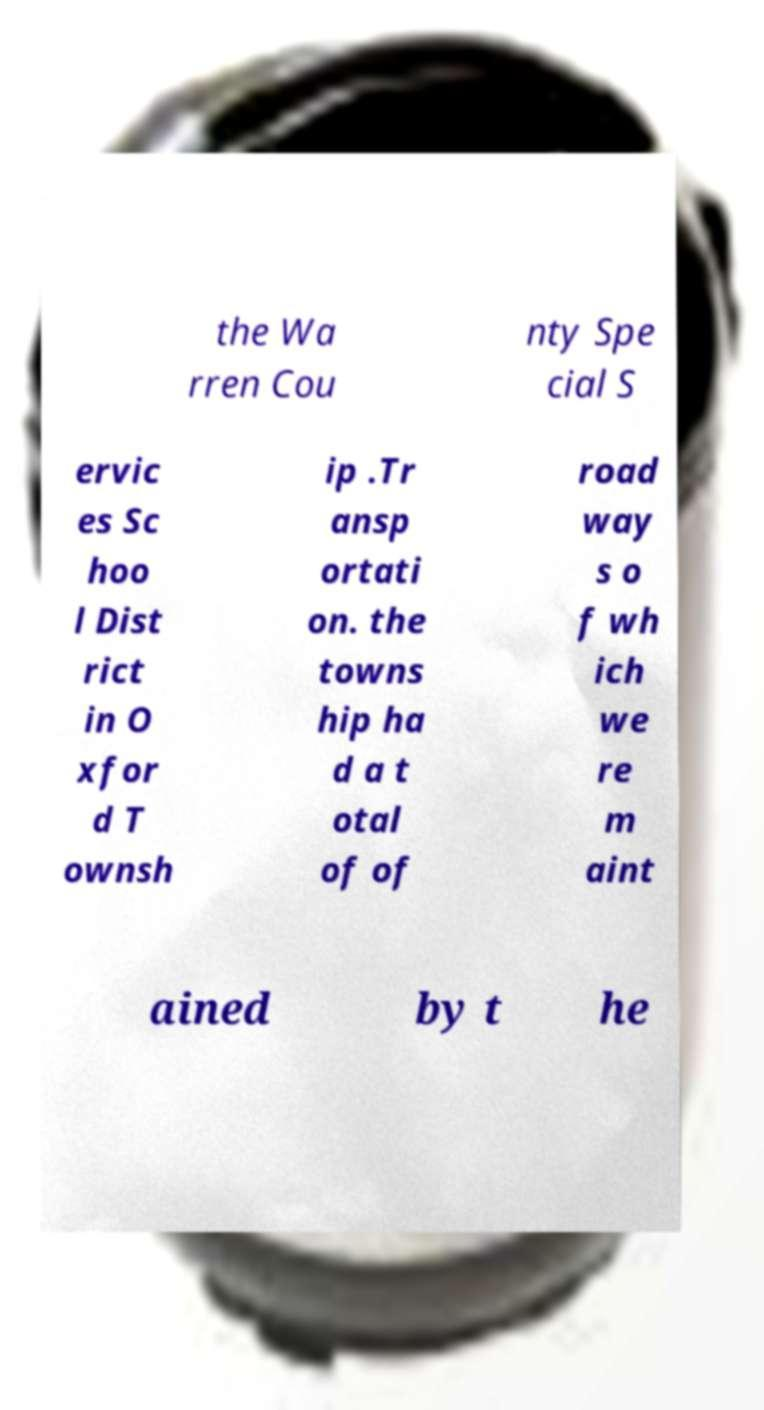There's text embedded in this image that I need extracted. Can you transcribe it verbatim? the Wa rren Cou nty Spe cial S ervic es Sc hoo l Dist rict in O xfor d T ownsh ip .Tr ansp ortati on. the towns hip ha d a t otal of of road way s o f wh ich we re m aint ained by t he 